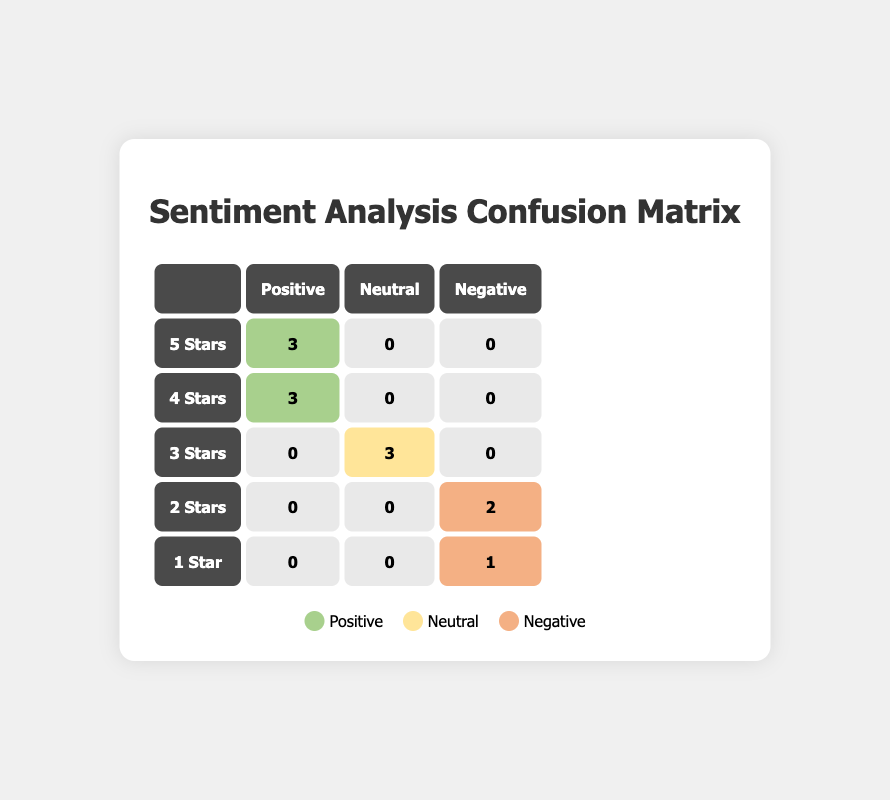What is the total number of reviews with a positive sentiment? To find the total number of reviews with a positive sentiment, we look at the positive values in the confusion matrix. The positive sentiment appears in the cells for 5 stars (3), 4 stars (3), which totals to 6.
Answer: 6 How many 4-star reviews were categorized as neutral? In the confusion matrix, the entry for 4-star reviews under the neutral sentiment is 0.
Answer: 0 What is the difference between the number of negative and positive sentiment analyses for 2-star ratings? For 2-star ratings, there are 0 positive sentiment analyses and 2 negative sentiment analyses. The difference is 0 - 2 = -2.
Answer: -2 Did any products with 3-star ratings have a positive sentiment? Looking at the confusion matrix, there are 0 entries under the positive sentiment for 3-star ratings, so the statement is false.
Answer: No How many total reviews received a neutral sentiment? To calculate the total neutral sentiment reviews, we sum the entries under the neutral column. The entries are for 3 stars (3), and there are no entries in the other rows, totaling 3.
Answer: 3 What percentage of the reviews that received 5 stars had a positive sentiment? The 5-star entry has a positive sentiment of 3 out of 3 total entries (3 positive, 0 neutral, 0 negative), which results in a percentage of (3/3) * 100 = 100%.
Answer: 100% Which rating had the most neutral sentiment analyses? The 3-star rating received the most neutral sentiment analyses with a total of 3 entries, compared to others which had either 0 or 1.
Answer: 3 stars How many negative sentiments were recorded for products rated 1 star? The confusion matrix shows that only 1 negative sentiment is recorded for the 1-star rating.
Answer: 1 What is the total count of products that received a 5-star rating? According to the confusion matrix, the only entry for a 5-star rating with a positive sentiment is 3, indicating 3 products received a 5-star rating.
Answer: 3 